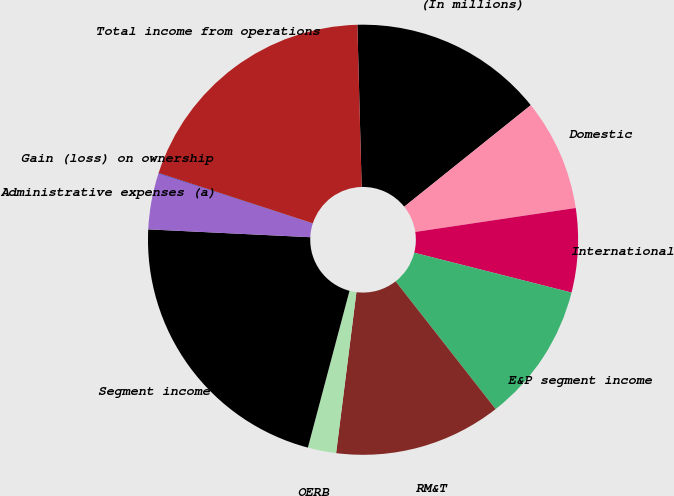Convert chart. <chart><loc_0><loc_0><loc_500><loc_500><pie_chart><fcel>(In millions)<fcel>Domestic<fcel>International<fcel>E&P segment income<fcel>RM&T<fcel>OERB<fcel>Segment income<fcel>Administrative expenses (a)<fcel>Gain (loss) on ownership<fcel>Total income from operations<nl><fcel>14.66%<fcel>8.4%<fcel>6.31%<fcel>10.48%<fcel>12.57%<fcel>2.13%<fcel>21.64%<fcel>4.22%<fcel>0.04%<fcel>19.55%<nl></chart> 